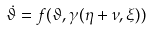<formula> <loc_0><loc_0><loc_500><loc_500>\dot { \vartheta } = f ( \vartheta , \gamma ( \eta + \nu , \xi ) )</formula> 